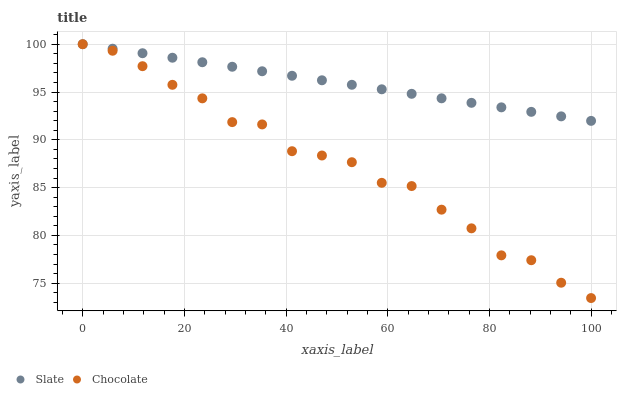Does Chocolate have the minimum area under the curve?
Answer yes or no. Yes. Does Slate have the maximum area under the curve?
Answer yes or no. Yes. Does Chocolate have the maximum area under the curve?
Answer yes or no. No. Is Slate the smoothest?
Answer yes or no. Yes. Is Chocolate the roughest?
Answer yes or no. Yes. Is Chocolate the smoothest?
Answer yes or no. No. Does Chocolate have the lowest value?
Answer yes or no. Yes. Does Chocolate have the highest value?
Answer yes or no. Yes. Does Slate intersect Chocolate?
Answer yes or no. Yes. Is Slate less than Chocolate?
Answer yes or no. No. Is Slate greater than Chocolate?
Answer yes or no. No. 